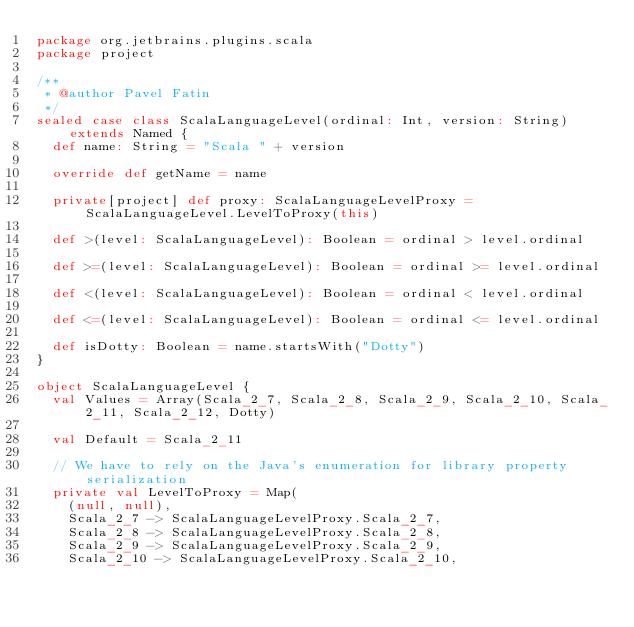<code> <loc_0><loc_0><loc_500><loc_500><_Scala_>package org.jetbrains.plugins.scala
package project

/**
 * @author Pavel Fatin
 */
sealed case class ScalaLanguageLevel(ordinal: Int, version: String) extends Named {
  def name: String = "Scala " + version

  override def getName = name

  private[project] def proxy: ScalaLanguageLevelProxy = ScalaLanguageLevel.LevelToProxy(this)

  def >(level: ScalaLanguageLevel): Boolean = ordinal > level.ordinal

  def >=(level: ScalaLanguageLevel): Boolean = ordinal >= level.ordinal

  def <(level: ScalaLanguageLevel): Boolean = ordinal < level.ordinal

  def <=(level: ScalaLanguageLevel): Boolean = ordinal <= level.ordinal

  def isDotty: Boolean = name.startsWith("Dotty")
}

object ScalaLanguageLevel {
  val Values = Array(Scala_2_7, Scala_2_8, Scala_2_9, Scala_2_10, Scala_2_11, Scala_2_12, Dotty)

  val Default = Scala_2_11

  // We have to rely on the Java's enumeration for library property serialization
  private val LevelToProxy = Map(
    (null, null),
    Scala_2_7 -> ScalaLanguageLevelProxy.Scala_2_7,
    Scala_2_8 -> ScalaLanguageLevelProxy.Scala_2_8,
    Scala_2_9 -> ScalaLanguageLevelProxy.Scala_2_9,
    Scala_2_10 -> ScalaLanguageLevelProxy.Scala_2_10,</code> 